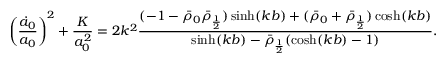Convert formula to latex. <formula><loc_0><loc_0><loc_500><loc_500>\left ( \frac { \dot { a } _ { 0 } } { a _ { 0 } } \right ) ^ { 2 } + \frac { K } { a _ { 0 } ^ { 2 } } = 2 k ^ { 2 } \frac { ( - 1 - \bar { \rho } _ { 0 } \bar { \rho } _ { \frac { 1 } { 2 } } ) \sinh ( k b ) + ( \bar { \rho } _ { 0 } + \bar { \rho } _ { \frac { 1 } { 2 } } ) \cosh ( k b ) } { \sinh ( k b ) - \bar { \rho } _ { \frac { 1 } { 2 } } ( \cosh ( k b ) - 1 ) } .</formula> 